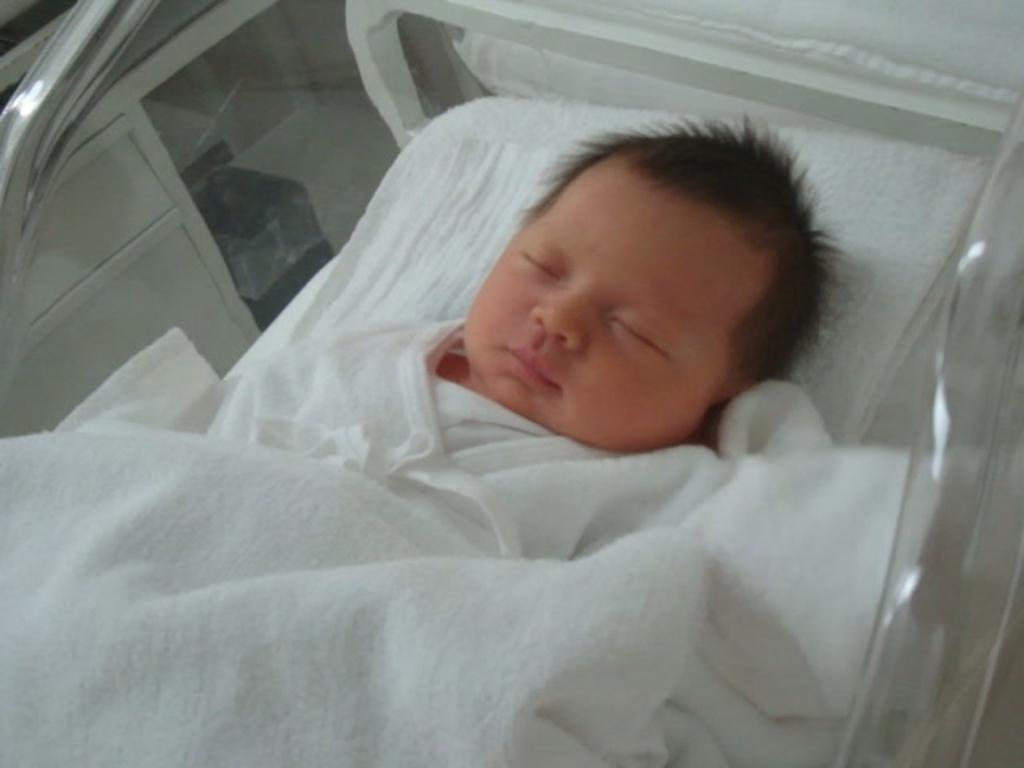What is the main subject of the image? The main subject of the image is a small baby. Can you describe the baby's location in the image? The baby appears to be inside a cradle. What type of pot is being used to fan the baby in the image? There is no pot or fan present in the image; it only features a small baby inside a cradle. 